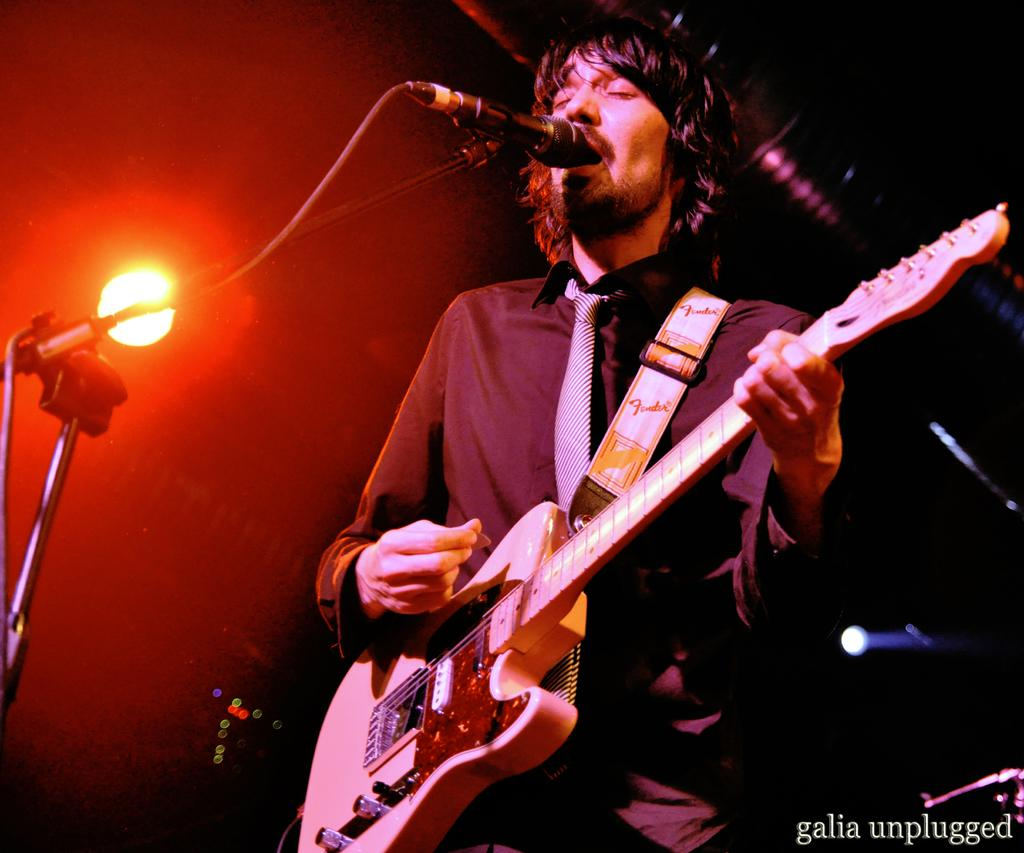What is the main subject of the image? There is a man in the image. What is the man wearing? The man is wearing a black shirt. What is the man doing in the image? The man is singing. What object is the man using to amplify his voice? There is a microphone in the image. What is the microphone attached to? There is a microphone stand in the image. What can be seen in the background of the image? There is a red light in the background of the image. What is the purpose of the toad in the image? There is no toad present in the image. How does the man push the microphone stand while singing? The man is not pushing the microphone stand while singing; it is stationary in the image. 